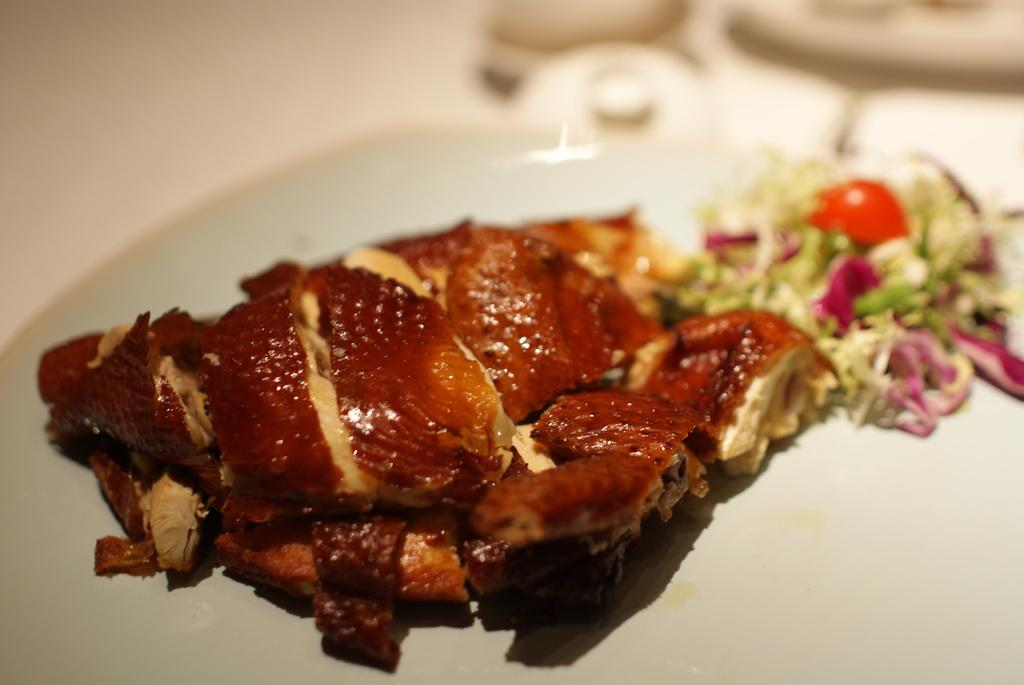What is present in the image that can be eaten? There are food items in the image. On what object are the food items placed? The food items are on an object that resembles a plate. Can you describe the background of the image? The background of the image is blurry. What direction is the rose facing in the image? There is no rose present in the image. How many clams are visible on the plate in the image? There is no mention of clams in the image; only food items are mentioned. 